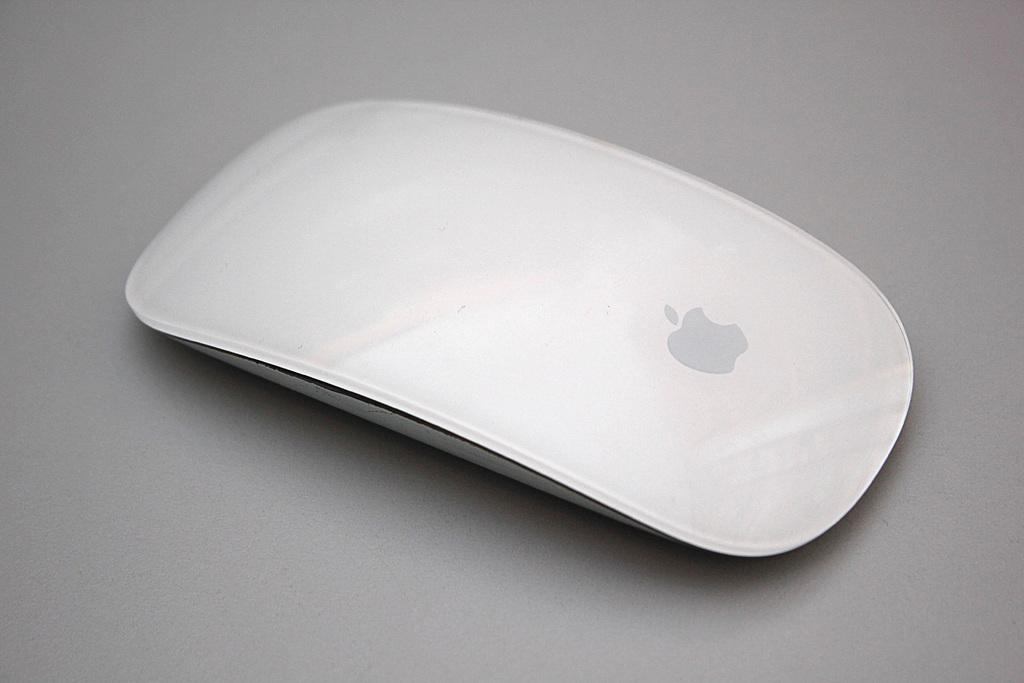What type of animal is in the image? There is a white mouse in the image. What is the color of the surface the mouse is on? The mouse is on a grey surface. Where can the shop selling paint be found in the image? There is no shop or paint present in the image; it only features a white mouse on a grey surface. 